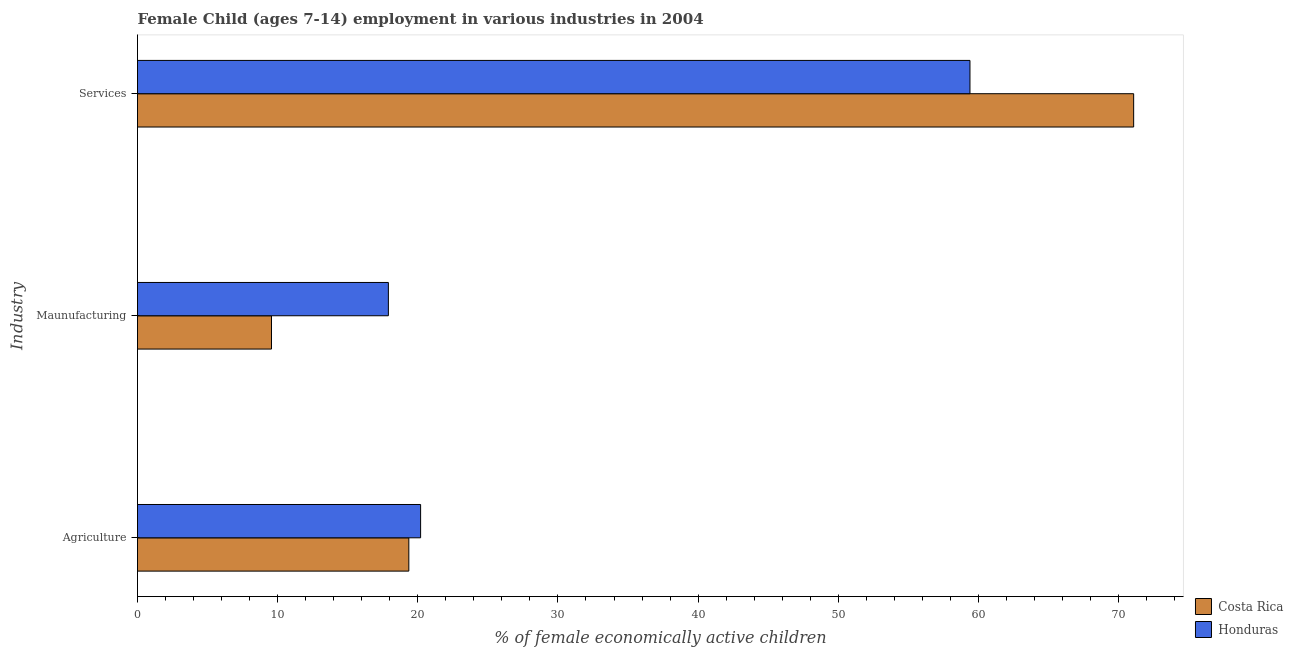How many different coloured bars are there?
Offer a very short reply. 2. How many groups of bars are there?
Ensure brevity in your answer.  3. Are the number of bars on each tick of the Y-axis equal?
Keep it short and to the point. Yes. How many bars are there on the 1st tick from the top?
Offer a very short reply. 2. How many bars are there on the 3rd tick from the bottom?
Your answer should be compact. 2. What is the label of the 1st group of bars from the top?
Offer a very short reply. Services. What is the percentage of economically active children in agriculture in Costa Rica?
Offer a very short reply. 19.36. Across all countries, what is the maximum percentage of economically active children in agriculture?
Provide a short and direct response. 20.2. Across all countries, what is the minimum percentage of economically active children in agriculture?
Your answer should be very brief. 19.36. In which country was the percentage of economically active children in manufacturing maximum?
Make the answer very short. Honduras. In which country was the percentage of economically active children in services minimum?
Make the answer very short. Honduras. What is the total percentage of economically active children in services in the graph?
Offer a terse response. 130.48. What is the difference between the percentage of economically active children in agriculture in Costa Rica and that in Honduras?
Provide a short and direct response. -0.84. What is the difference between the percentage of economically active children in services in Costa Rica and the percentage of economically active children in manufacturing in Honduras?
Offer a terse response. 53.18. What is the average percentage of economically active children in manufacturing per country?
Offer a terse response. 13.73. What is the difference between the percentage of economically active children in agriculture and percentage of economically active children in manufacturing in Costa Rica?
Give a very brief answer. 9.8. What is the ratio of the percentage of economically active children in services in Honduras to that in Costa Rica?
Keep it short and to the point. 0.84. Is the difference between the percentage of economically active children in agriculture in Costa Rica and Honduras greater than the difference between the percentage of economically active children in manufacturing in Costa Rica and Honduras?
Your answer should be compact. Yes. What is the difference between the highest and the second highest percentage of economically active children in agriculture?
Your answer should be compact. 0.84. What is the difference between the highest and the lowest percentage of economically active children in manufacturing?
Offer a very short reply. 8.34. In how many countries, is the percentage of economically active children in agriculture greater than the average percentage of economically active children in agriculture taken over all countries?
Make the answer very short. 1. What does the 1st bar from the top in Maunufacturing represents?
Keep it short and to the point. Honduras. What does the 2nd bar from the bottom in Agriculture represents?
Provide a short and direct response. Honduras. How many bars are there?
Offer a terse response. 6. How many countries are there in the graph?
Keep it short and to the point. 2. Are the values on the major ticks of X-axis written in scientific E-notation?
Keep it short and to the point. No. Does the graph contain grids?
Give a very brief answer. No. Where does the legend appear in the graph?
Give a very brief answer. Bottom right. How are the legend labels stacked?
Keep it short and to the point. Vertical. What is the title of the graph?
Offer a very short reply. Female Child (ages 7-14) employment in various industries in 2004. What is the label or title of the X-axis?
Provide a short and direct response. % of female economically active children. What is the label or title of the Y-axis?
Give a very brief answer. Industry. What is the % of female economically active children of Costa Rica in Agriculture?
Your answer should be compact. 19.36. What is the % of female economically active children in Honduras in Agriculture?
Give a very brief answer. 20.2. What is the % of female economically active children in Costa Rica in Maunufacturing?
Keep it short and to the point. 9.56. What is the % of female economically active children of Honduras in Maunufacturing?
Ensure brevity in your answer.  17.9. What is the % of female economically active children in Costa Rica in Services?
Offer a terse response. 71.08. What is the % of female economically active children of Honduras in Services?
Give a very brief answer. 59.4. Across all Industry, what is the maximum % of female economically active children of Costa Rica?
Your response must be concise. 71.08. Across all Industry, what is the maximum % of female economically active children of Honduras?
Make the answer very short. 59.4. Across all Industry, what is the minimum % of female economically active children of Costa Rica?
Your answer should be very brief. 9.56. What is the total % of female economically active children in Costa Rica in the graph?
Provide a short and direct response. 100. What is the total % of female economically active children in Honduras in the graph?
Provide a short and direct response. 97.5. What is the difference between the % of female economically active children of Honduras in Agriculture and that in Maunufacturing?
Ensure brevity in your answer.  2.3. What is the difference between the % of female economically active children of Costa Rica in Agriculture and that in Services?
Offer a very short reply. -51.72. What is the difference between the % of female economically active children in Honduras in Agriculture and that in Services?
Offer a terse response. -39.2. What is the difference between the % of female economically active children in Costa Rica in Maunufacturing and that in Services?
Your answer should be compact. -61.52. What is the difference between the % of female economically active children of Honduras in Maunufacturing and that in Services?
Provide a succinct answer. -41.5. What is the difference between the % of female economically active children in Costa Rica in Agriculture and the % of female economically active children in Honduras in Maunufacturing?
Provide a short and direct response. 1.46. What is the difference between the % of female economically active children in Costa Rica in Agriculture and the % of female economically active children in Honduras in Services?
Your answer should be very brief. -40.04. What is the difference between the % of female economically active children of Costa Rica in Maunufacturing and the % of female economically active children of Honduras in Services?
Offer a very short reply. -49.84. What is the average % of female economically active children of Costa Rica per Industry?
Keep it short and to the point. 33.33. What is the average % of female economically active children in Honduras per Industry?
Offer a very short reply. 32.5. What is the difference between the % of female economically active children in Costa Rica and % of female economically active children in Honduras in Agriculture?
Your answer should be compact. -0.84. What is the difference between the % of female economically active children in Costa Rica and % of female economically active children in Honduras in Maunufacturing?
Offer a very short reply. -8.34. What is the difference between the % of female economically active children of Costa Rica and % of female economically active children of Honduras in Services?
Give a very brief answer. 11.68. What is the ratio of the % of female economically active children of Costa Rica in Agriculture to that in Maunufacturing?
Your response must be concise. 2.03. What is the ratio of the % of female economically active children of Honduras in Agriculture to that in Maunufacturing?
Your answer should be very brief. 1.13. What is the ratio of the % of female economically active children in Costa Rica in Agriculture to that in Services?
Offer a very short reply. 0.27. What is the ratio of the % of female economically active children of Honduras in Agriculture to that in Services?
Offer a very short reply. 0.34. What is the ratio of the % of female economically active children of Costa Rica in Maunufacturing to that in Services?
Your answer should be very brief. 0.13. What is the ratio of the % of female economically active children of Honduras in Maunufacturing to that in Services?
Offer a very short reply. 0.3. What is the difference between the highest and the second highest % of female economically active children in Costa Rica?
Your response must be concise. 51.72. What is the difference between the highest and the second highest % of female economically active children in Honduras?
Ensure brevity in your answer.  39.2. What is the difference between the highest and the lowest % of female economically active children in Costa Rica?
Your response must be concise. 61.52. What is the difference between the highest and the lowest % of female economically active children of Honduras?
Offer a very short reply. 41.5. 